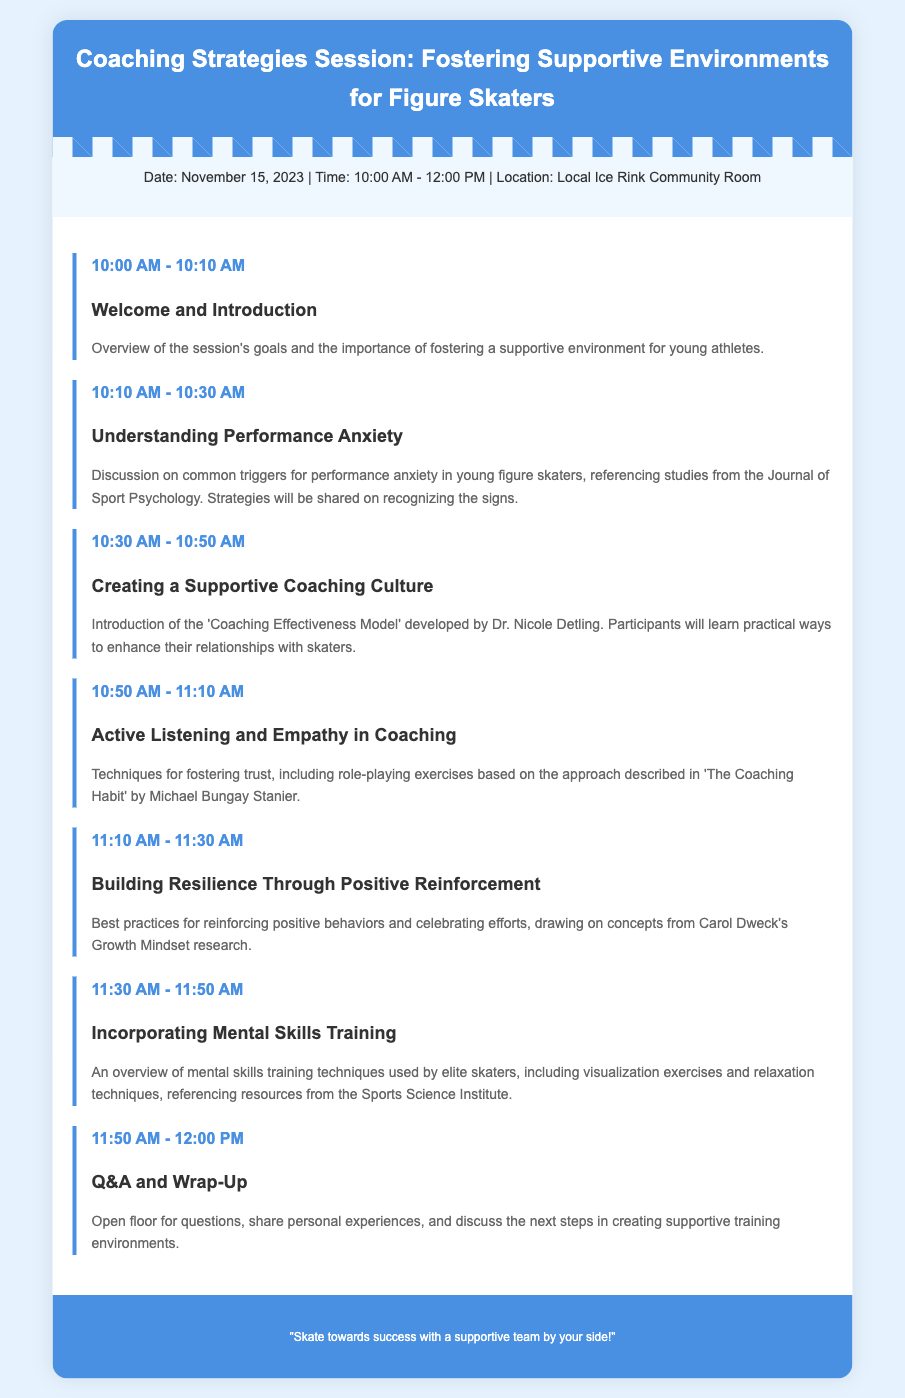What is the date of the session? The date of the session is mentioned in the document as November 15, 2023.
Answer: November 15, 2023 What time does the session start? The starting time of the session is listed in the document as 10:00 AM.
Answer: 10:00 AM What is discussed during the "Understanding Performance Anxiety" segment? The segment discusses triggers for performance anxiety in young skaters and strategies for recognizing signs.
Answer: Triggers for performance anxiety Who developed the "Coaching Effectiveness Model"? The document states that the model was developed by Dr. Nicole Detling.
Answer: Dr. Nicole Detling What technique is emphasized in the "Active Listening and Empathy in Coaching"? The technique emphasized is role-playing exercises based on a specific coaching approach.
Answer: Role-playing exercises What concept is linked to building resilience in skaters? The document connects building resilience with positive reinforcement practices.
Answer: Positive reinforcement How long is the Q&A and Wrap-Up session? The duration for the Q&A and Wrap-Up session is specified as 10 minutes.
Answer: 10 minutes What is the final message in the document? The final message encourages a supportive team environment for success in skating.
Answer: "Skate towards success with a supportive team by your side!" 